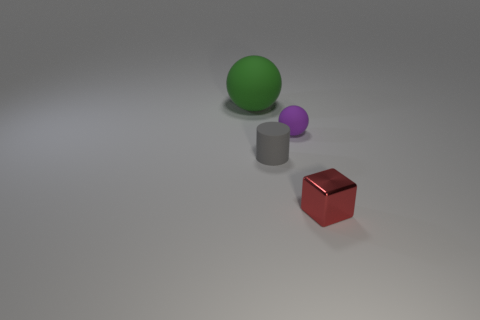Add 1 large purple metal balls. How many objects exist? 5 Subtract all cylinders. How many objects are left? 3 Add 4 matte spheres. How many matte spheres exist? 6 Subtract 1 red cubes. How many objects are left? 3 Subtract all large red cylinders. Subtract all gray rubber cylinders. How many objects are left? 3 Add 1 purple matte things. How many purple matte things are left? 2 